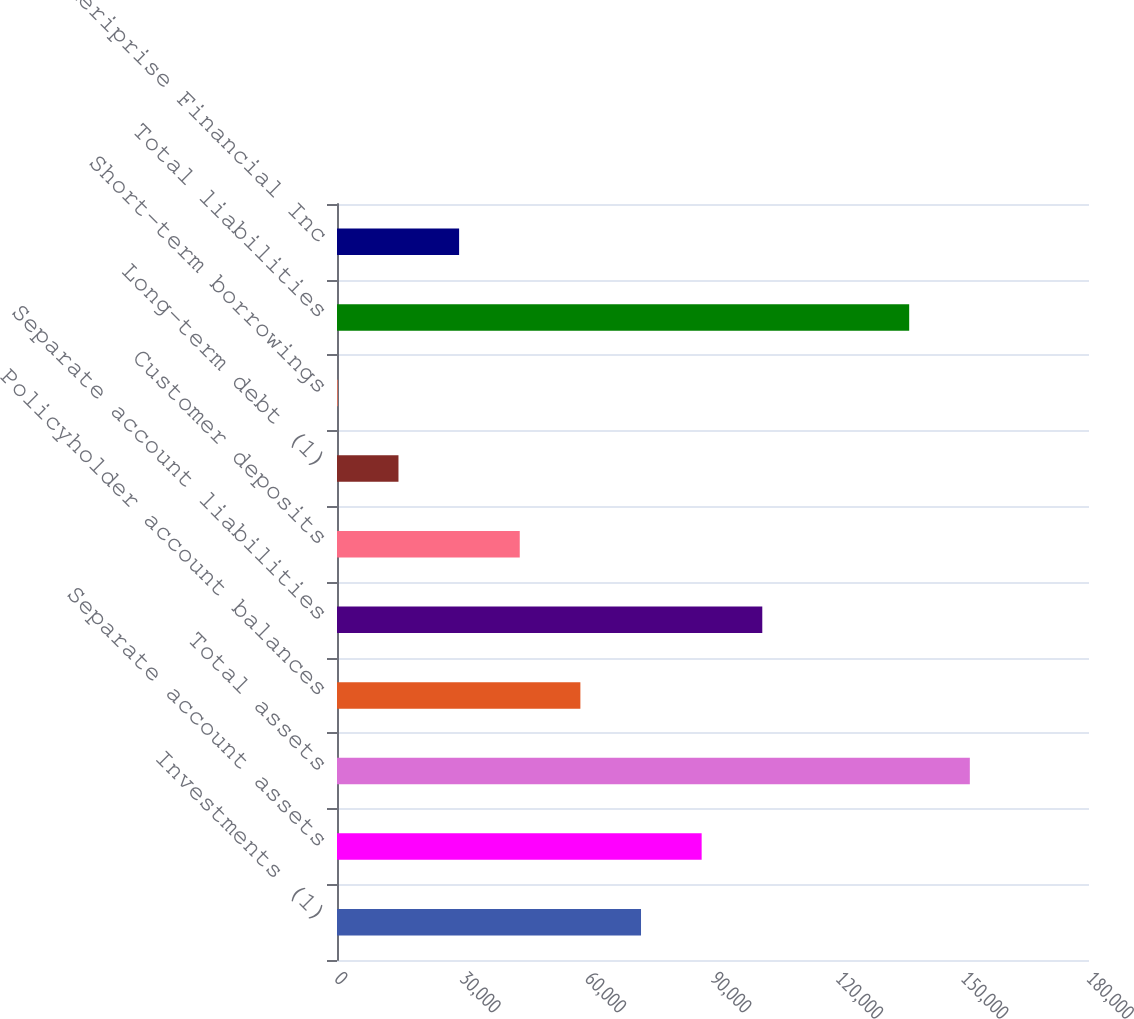Convert chart to OTSL. <chart><loc_0><loc_0><loc_500><loc_500><bar_chart><fcel>Investments (1)<fcel>Separate account assets<fcel>Total assets<fcel>Policyholder account balances<fcel>Separate account liabilities<fcel>Customer deposits<fcel>Long-term debt (1)<fcel>Short-term borrowings<fcel>Total liabilities<fcel>Total Ameriprise Financial Inc<nl><fcel>72769.5<fcel>87283.4<fcel>151474<fcel>58255.6<fcel>101797<fcel>43741.7<fcel>14713.9<fcel>200<fcel>136960<fcel>29227.8<nl></chart> 